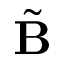<formula> <loc_0><loc_0><loc_500><loc_500>\tilde { \mathbf B }</formula> 